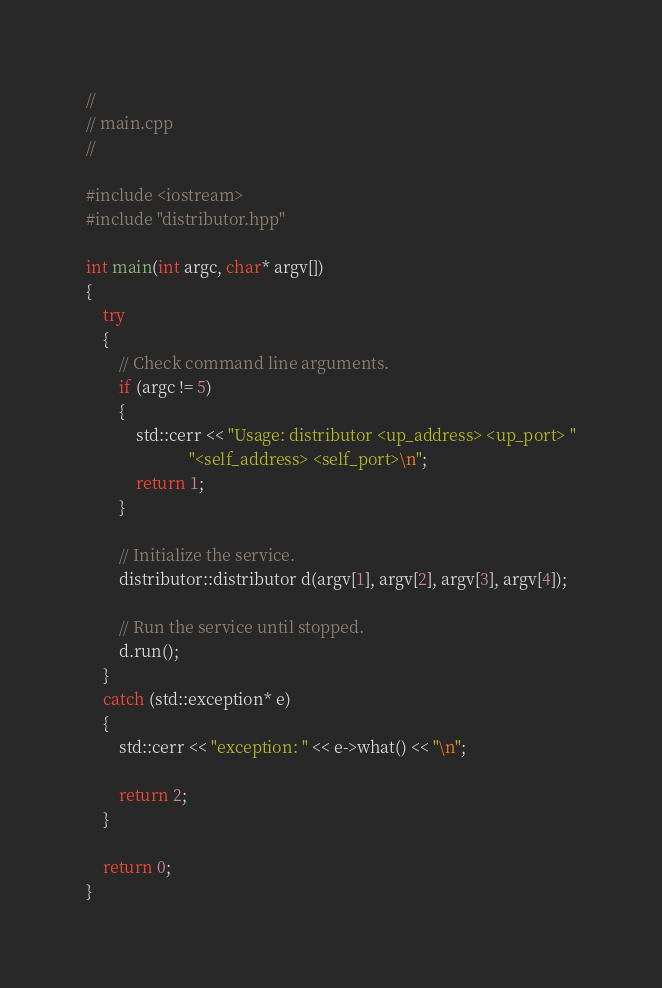<code> <loc_0><loc_0><loc_500><loc_500><_C++_>//
// main.cpp
//

#include <iostream>
#include "distributor.hpp"

int main(int argc, char* argv[])
{
    try
    {
        // Check command line arguments.
        if (argc != 5)
        {
            std::cerr << "Usage: distributor <up_address> <up_port> "
                         "<self_address> <self_port>\n";
            return 1;
        }
        
        // Initialize the service.
        distributor::distributor d(argv[1], argv[2], argv[3], argv[4]);

        // Run the service until stopped.
        d.run();
    }
    catch (std::exception* e)
    {
        std::cerr << "exception: " << e->what() << "\n";

        return 2;
    }

    return 0;
}
</code> 